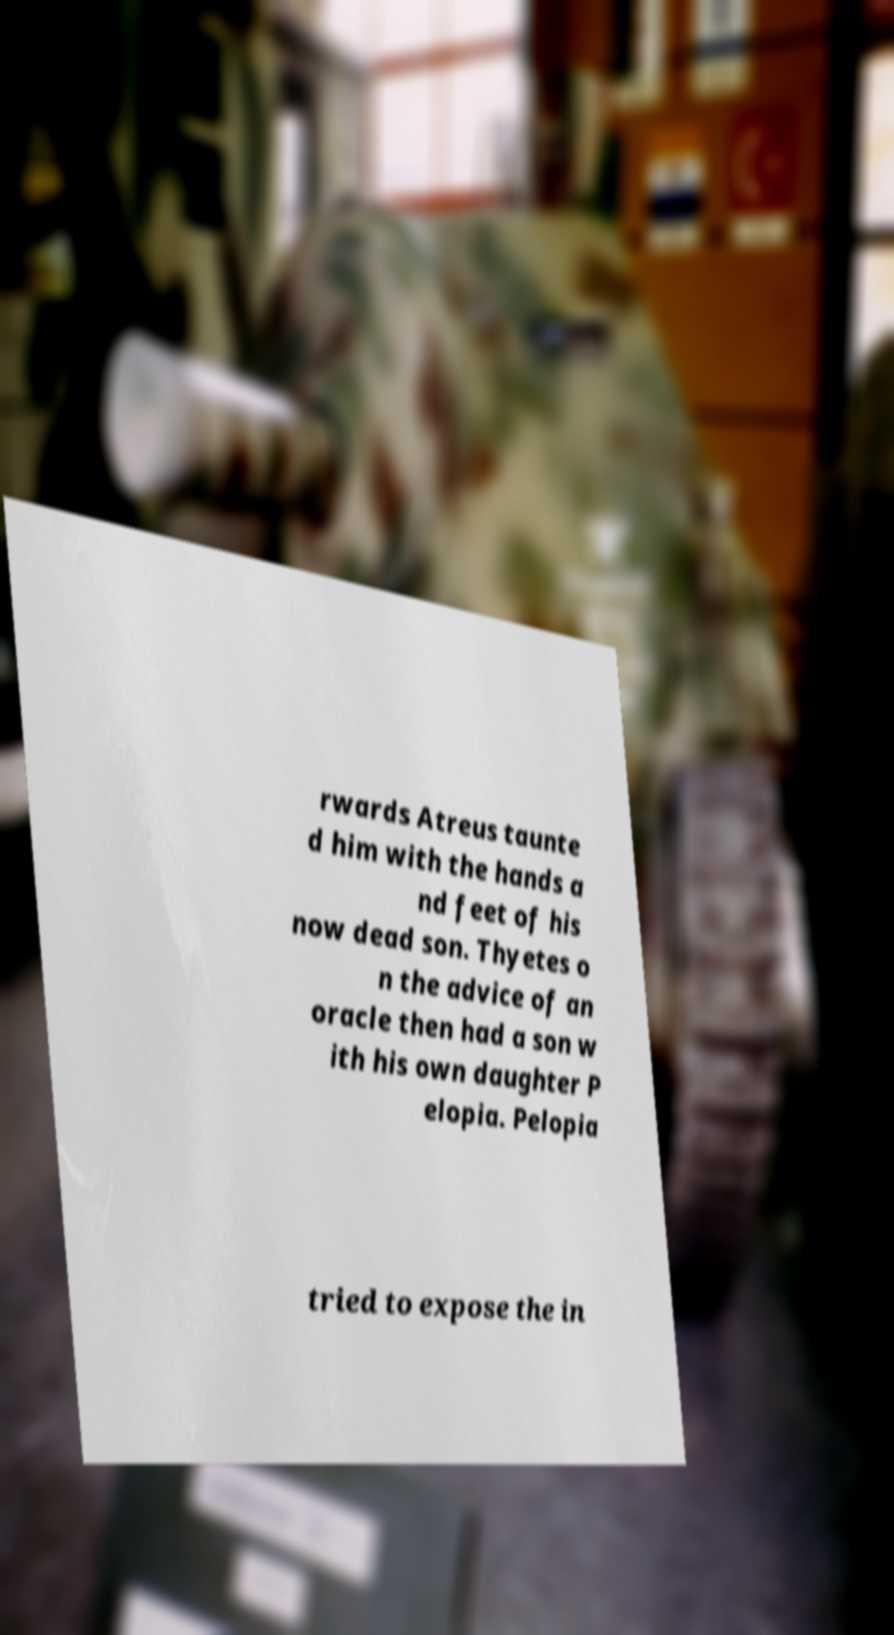Please read and relay the text visible in this image. What does it say? rwards Atreus taunte d him with the hands a nd feet of his now dead son. Thyetes o n the advice of an oracle then had a son w ith his own daughter P elopia. Pelopia tried to expose the in 